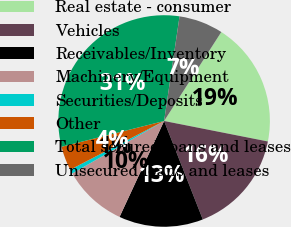Convert chart to OTSL. <chart><loc_0><loc_0><loc_500><loc_500><pie_chart><fcel>Real estate - consumer<fcel>Vehicles<fcel>Receivables/Inventory<fcel>Machinery/Equipment<fcel>Securities/Deposits<fcel>Other<fcel>Total secured loans and leases<fcel>Unsecured loans and leases<nl><fcel>19.01%<fcel>15.94%<fcel>12.88%<fcel>9.82%<fcel>0.64%<fcel>3.7%<fcel>31.25%<fcel>6.76%<nl></chart> 